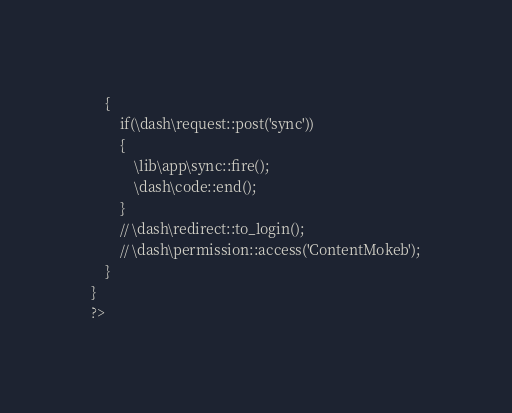<code> <loc_0><loc_0><loc_500><loc_500><_PHP_>	{
		if(\dash\request::post('sync'))
		{
			\lib\app\sync::fire();
			\dash\code::end();
		}
		// \dash\redirect::to_login();
		// \dash\permission::access('ContentMokeb');
	}
}
?></code> 